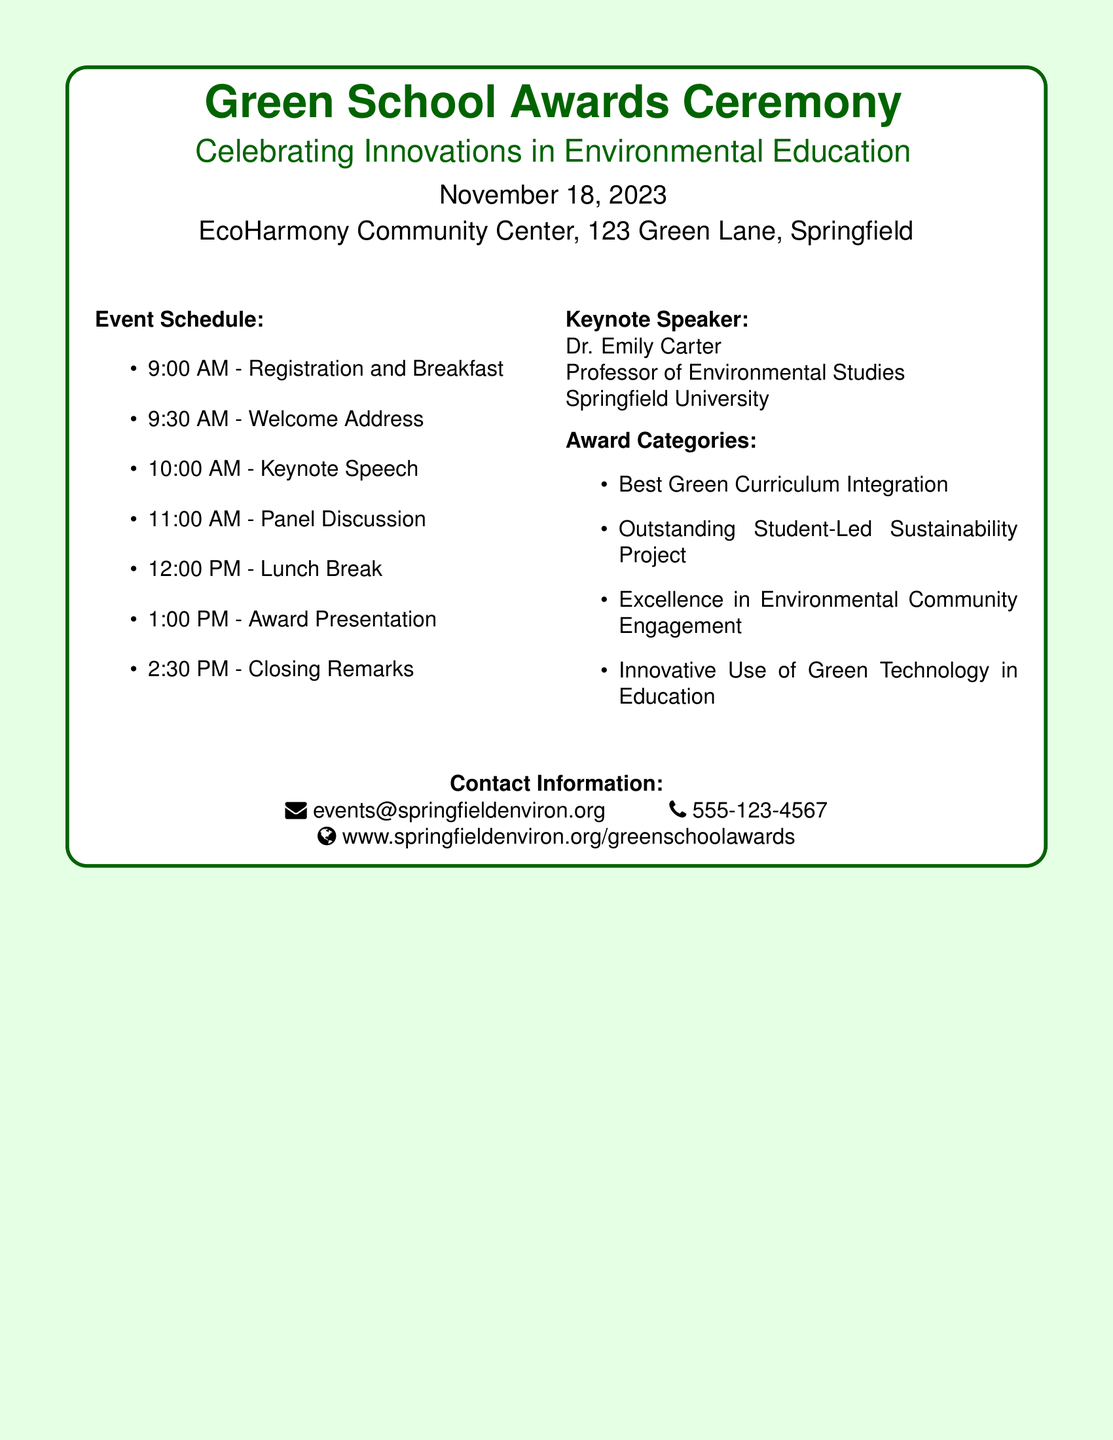What date is the event scheduled for? The date is explicitly mentioned in the document as November 18, 2023.
Answer: November 18, 2023 Who is the Keynote Speaker? The document clearly lists Dr. Emily Carter as the Keynote Speaker.
Answer: Dr. Emily Carter What time does registration start? The schedule indicates that registration begins at 9:00 AM.
Answer: 9:00 AM How many award categories are there? The document lists four distinct award categories under "Award Categories."
Answer: Four What is the location of the event? The venue is specified in the document as EcoHarmony Community Center, 123 Green Lane, Springfield.
Answer: EcoHarmony Community Center, 123 Green Lane, Springfield What is the first activity listed in the event schedule? The first activity in the event schedule is the "Registration and Breakfast."
Answer: Registration and Breakfast What will happen at 1:00 PM? The document states that the "Award Presentation" will occur at that time.
Answer: Award Presentation What is the theme of the event? The theme is implied in the title, “Celebrating Innovations in Environmental Education.”
Answer: Celebrating Innovations in Environmental Education 